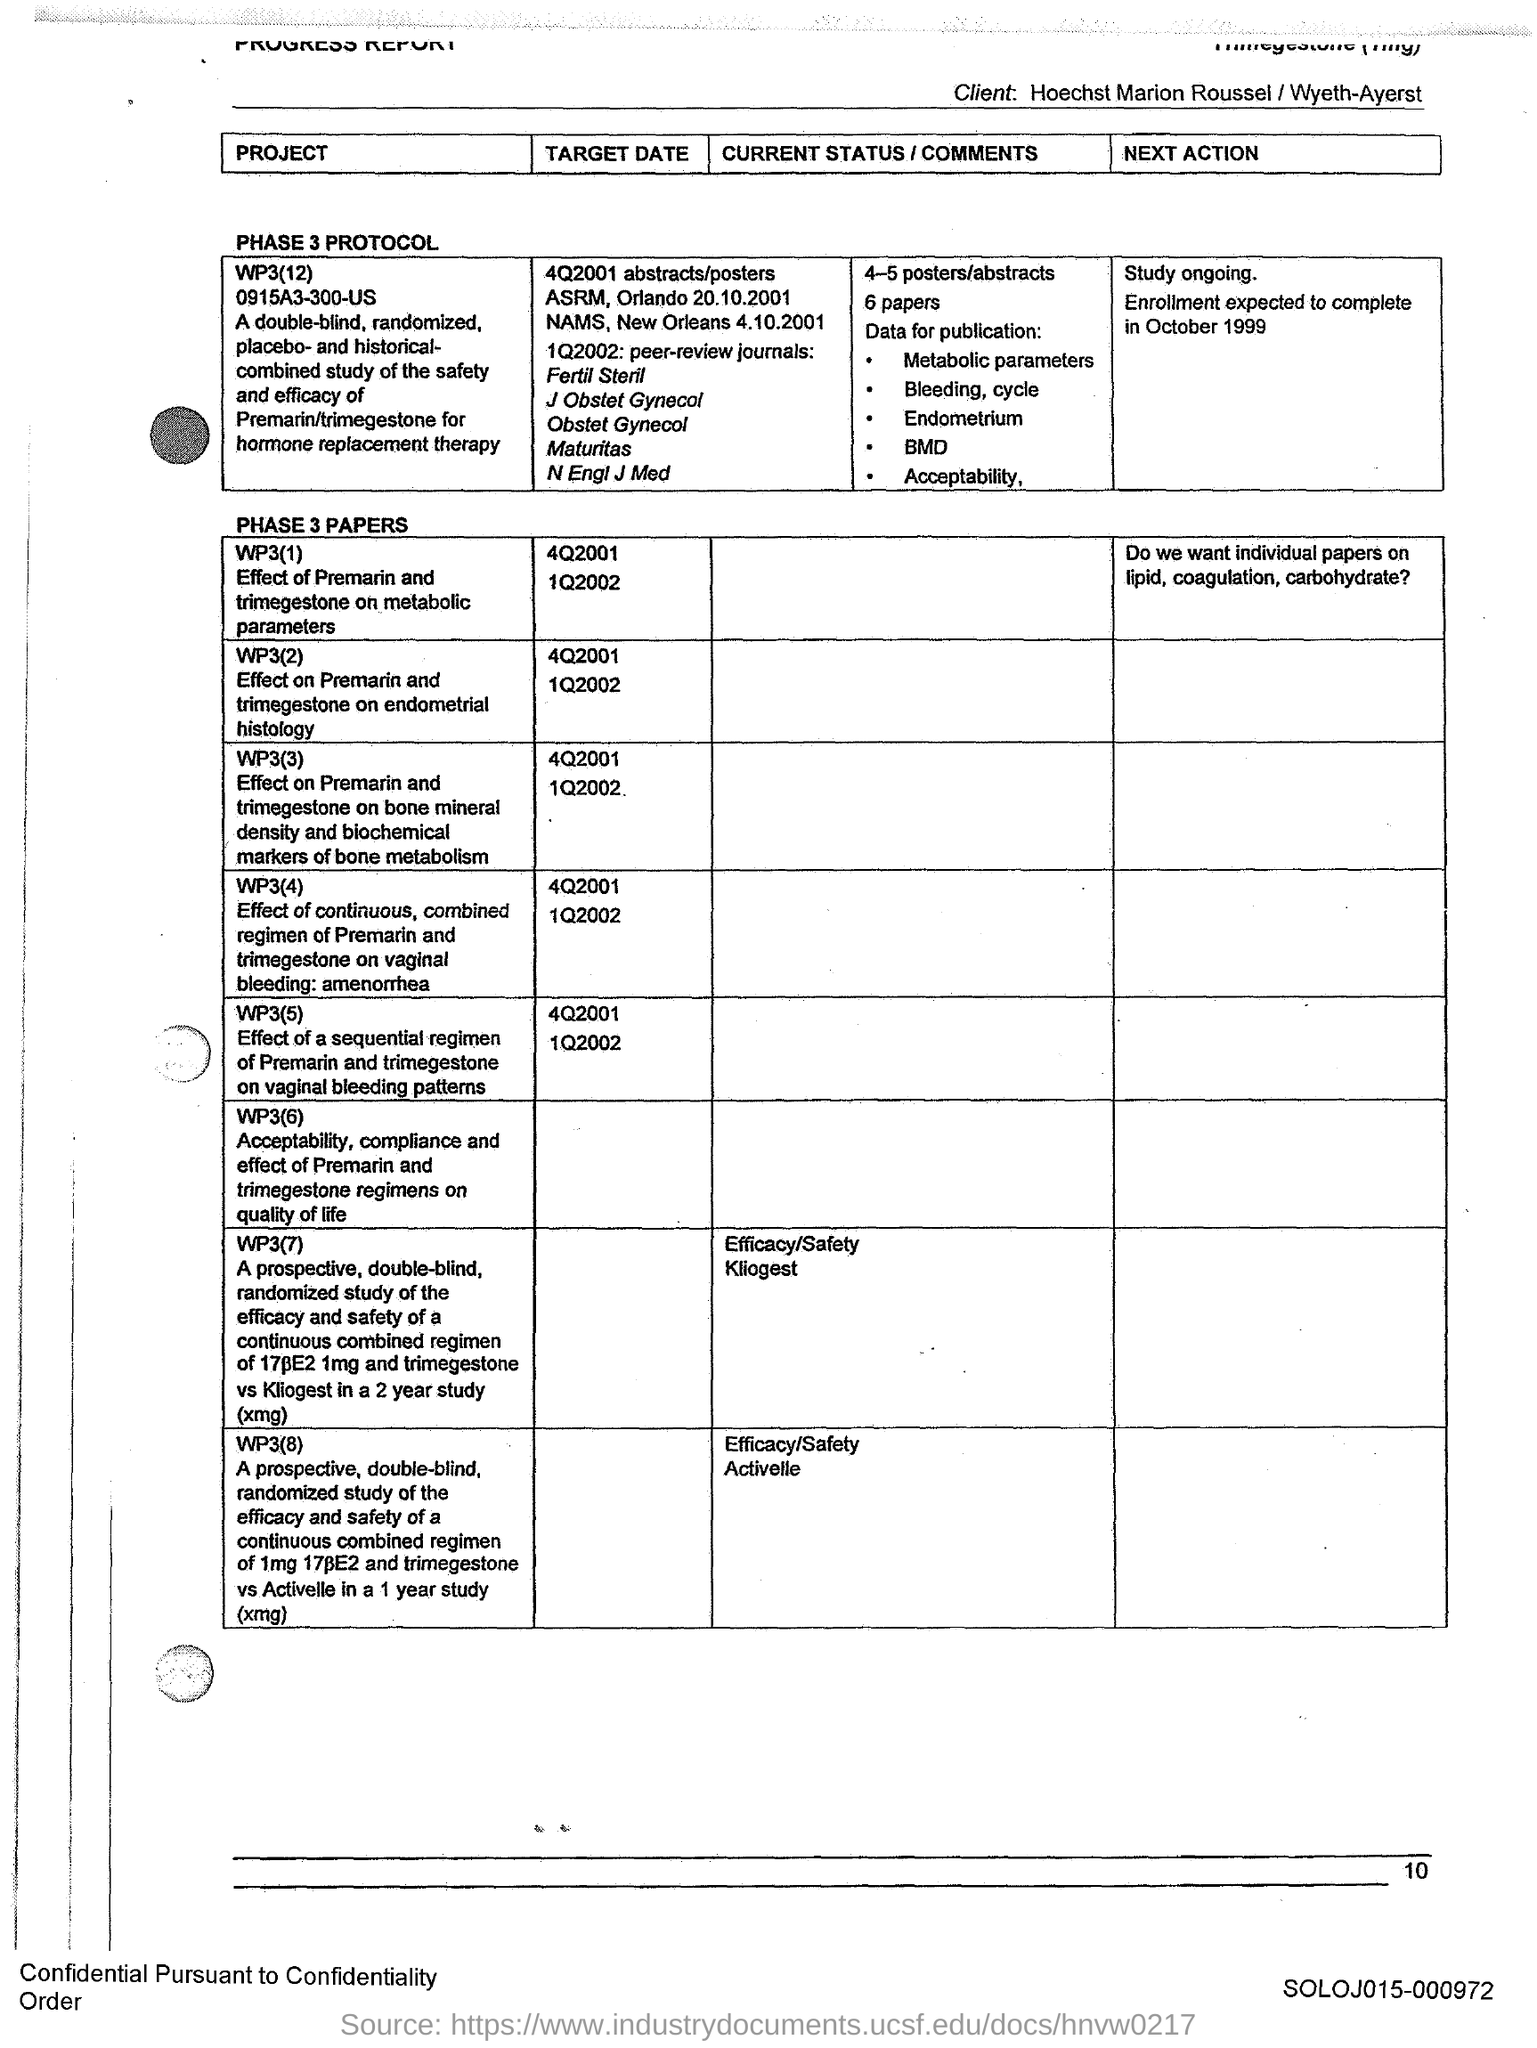Specify some key components in this picture. WP3(2) discusses the effects of Premarin and Trimegestone on endometrial histology. The code at the bottom of the page is "SOLOJ015-000972. 